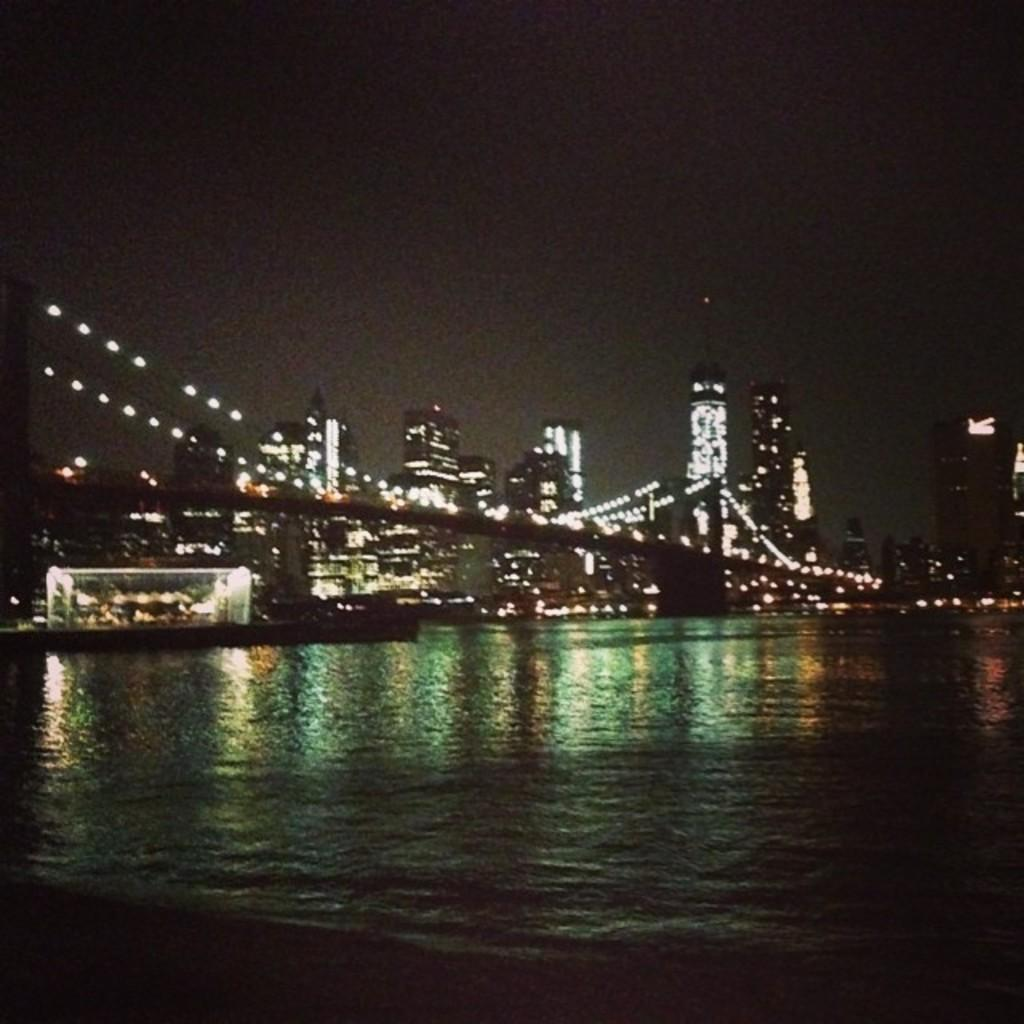What type of structures are illuminated in the image? There are buildings with lights in the image. What can be seen crossing over the water in the image? There is a bridge above the water in the image. What other sources of light are visible in the image? There are other lights visible in the image. What part of the natural environment is visible in the image? The sky is visible in the image. What thoughts are going through the mind of the bridge in the image? The bridge is an inanimate object and does not have a mind, so it cannot have thoughts. How does the society depicted in the image contribute to the lighting of the buildings? The image does not provide any information about a society, so we cannot determine how it might contribute to the lighting of the buildings. 